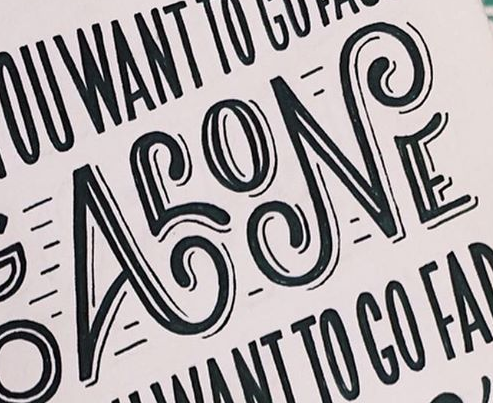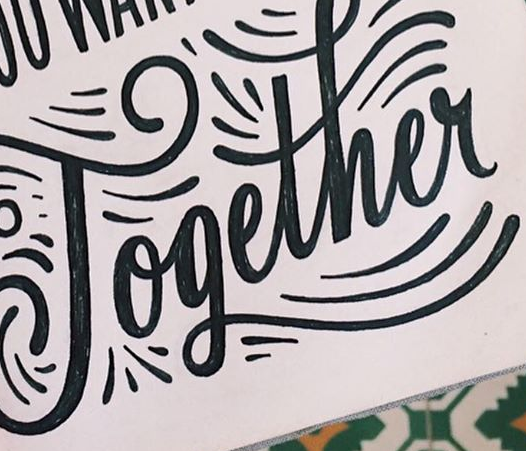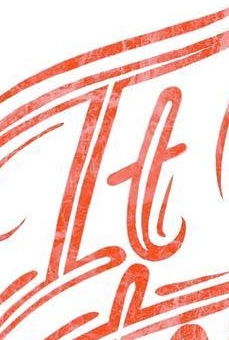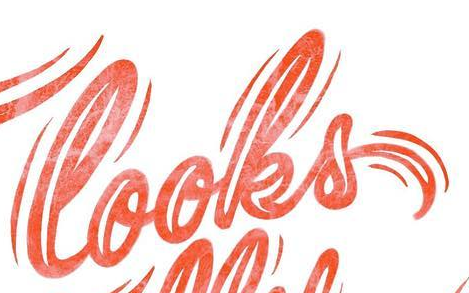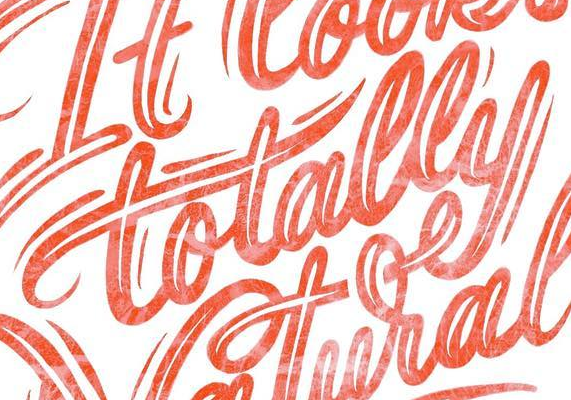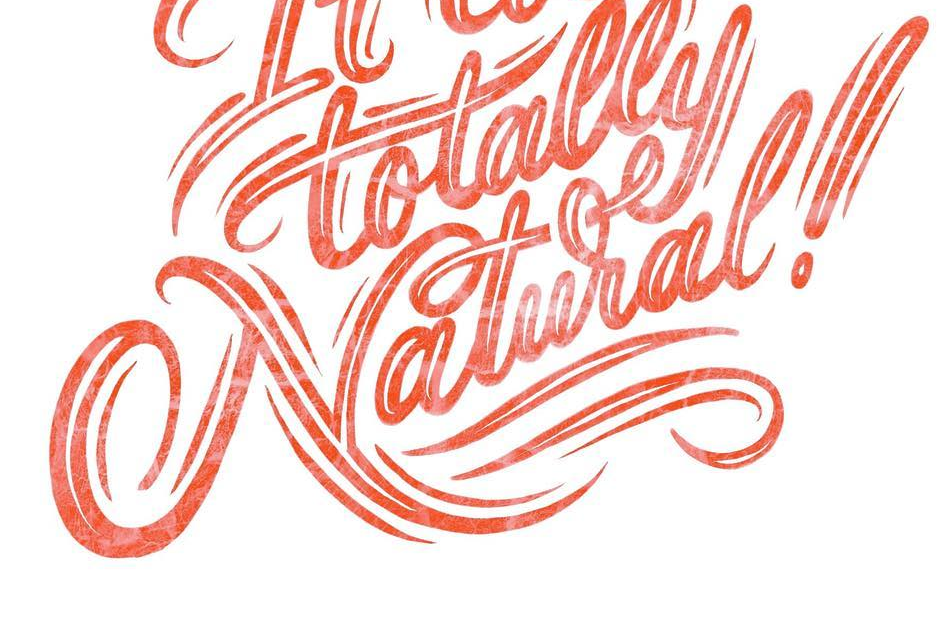Transcribe the words shown in these images in order, separated by a semicolon. ALONE; Together; It; looks; totally; Natural! 